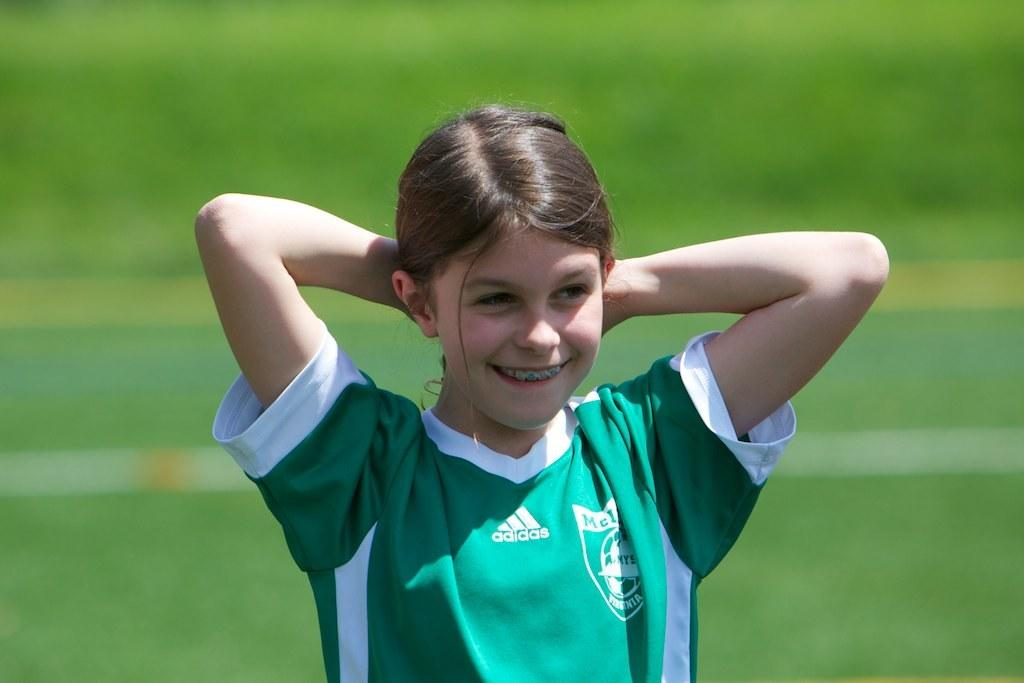<image>
Present a compact description of the photo's key features. A picture of a younger girl playing soccor, on the field, wearing her team jersey who is sponsered by Adidas. 